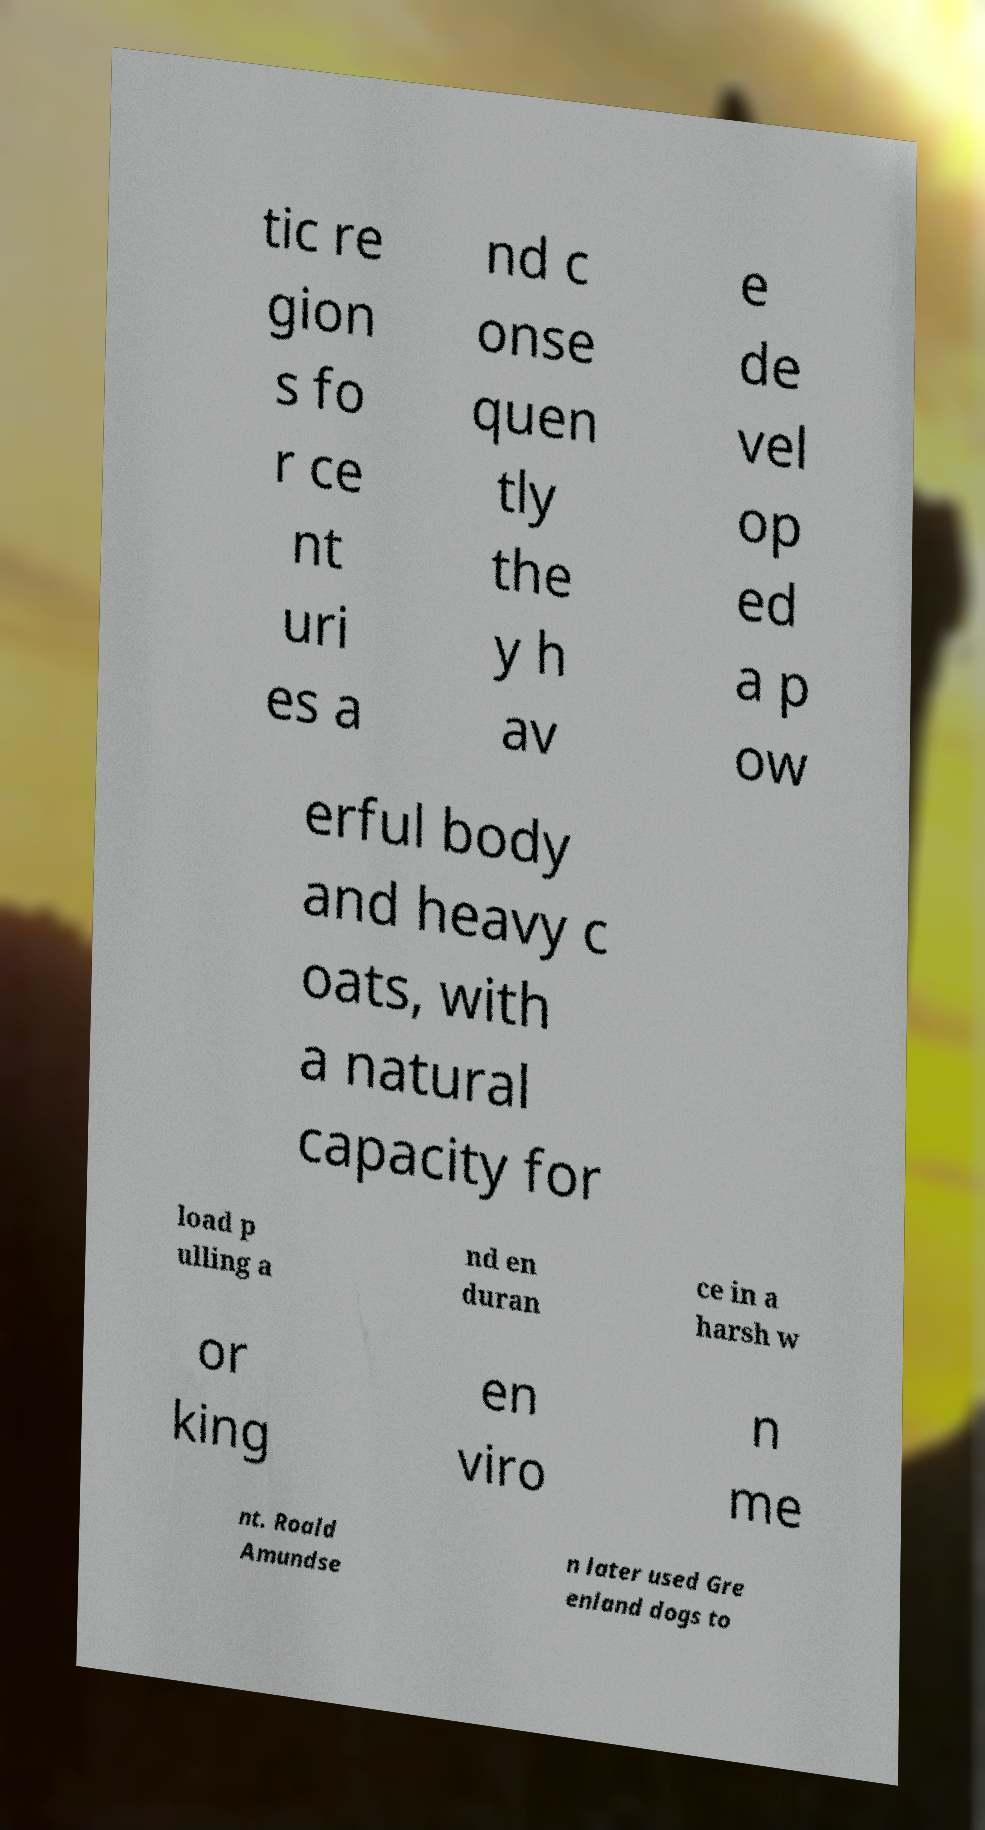Please identify and transcribe the text found in this image. tic re gion s fo r ce nt uri es a nd c onse quen tly the y h av e de vel op ed a p ow erful body and heavy c oats, with a natural capacity for load p ulling a nd en duran ce in a harsh w or king en viro n me nt. Roald Amundse n later used Gre enland dogs to 